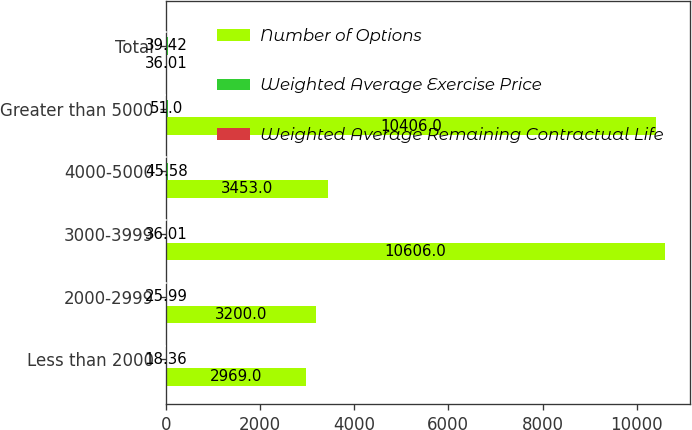Convert chart to OTSL. <chart><loc_0><loc_0><loc_500><loc_500><stacked_bar_chart><ecel><fcel>Less than 2000<fcel>2000-2999<fcel>3000-3999<fcel>4000-5000<fcel>Greater than 5000<fcel>Total<nl><fcel>Number of Options<fcel>2969<fcel>3200<fcel>10606<fcel>3453<fcel>10406<fcel>36.01<nl><fcel>Weighted Average Exercise Price<fcel>18.36<fcel>25.99<fcel>36.01<fcel>45.58<fcel>51<fcel>39.42<nl><fcel>Weighted Average Remaining Contractual Life<fcel>5.7<fcel>4.1<fcel>6.5<fcel>4.1<fcel>7.7<fcel>6.3<nl></chart> 